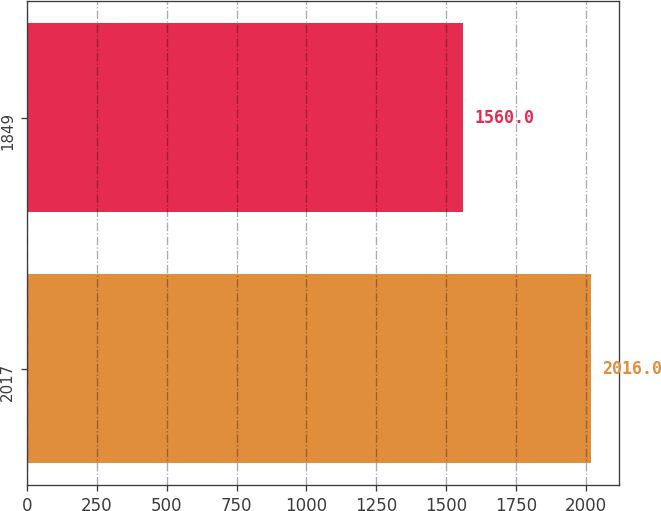Convert chart to OTSL. <chart><loc_0><loc_0><loc_500><loc_500><bar_chart><fcel>2017<fcel>1849<nl><fcel>2016<fcel>1560<nl></chart> 